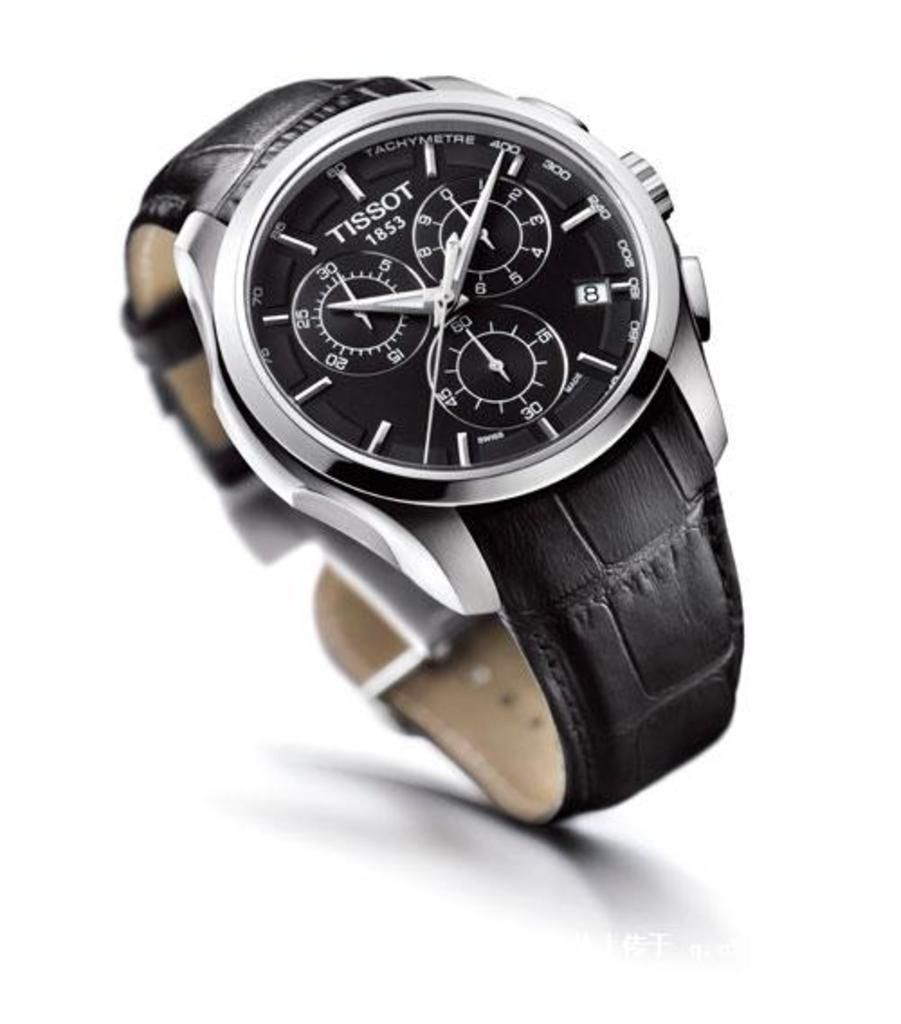<image>
Give a short and clear explanation of the subsequent image. A black and silver Tissot watch with a black leather wristband. 